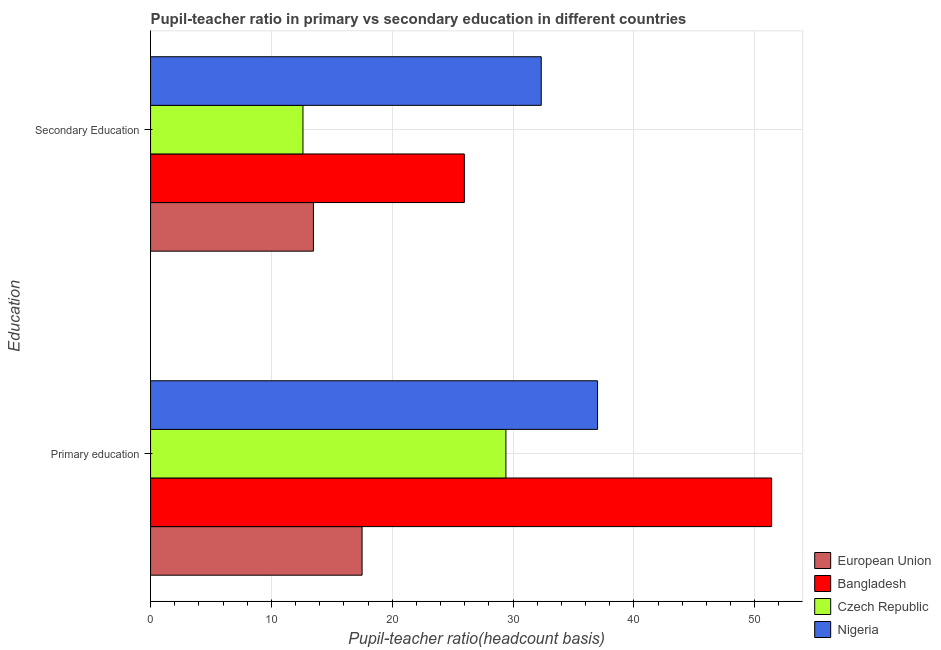How many different coloured bars are there?
Make the answer very short. 4. Are the number of bars per tick equal to the number of legend labels?
Offer a terse response. Yes. Are the number of bars on each tick of the Y-axis equal?
Your response must be concise. Yes. What is the label of the 1st group of bars from the top?
Your answer should be compact. Secondary Education. What is the pupil-teacher ratio in primary education in European Union?
Your answer should be very brief. 17.51. Across all countries, what is the maximum pupil teacher ratio on secondary education?
Offer a terse response. 32.34. Across all countries, what is the minimum pupil teacher ratio on secondary education?
Provide a short and direct response. 12.61. In which country was the pupil-teacher ratio in primary education maximum?
Provide a short and direct response. Bangladesh. What is the total pupil-teacher ratio in primary education in the graph?
Ensure brevity in your answer.  135.32. What is the difference between the pupil teacher ratio on secondary education in European Union and that in Nigeria?
Provide a succinct answer. -18.86. What is the difference between the pupil-teacher ratio in primary education in Czech Republic and the pupil teacher ratio on secondary education in Nigeria?
Your answer should be very brief. -2.92. What is the average pupil-teacher ratio in primary education per country?
Provide a short and direct response. 33.83. What is the difference between the pupil teacher ratio on secondary education and pupil-teacher ratio in primary education in Czech Republic?
Offer a very short reply. -16.8. In how many countries, is the pupil-teacher ratio in primary education greater than 38 ?
Keep it short and to the point. 1. What is the ratio of the pupil-teacher ratio in primary education in Czech Republic to that in Bangladesh?
Offer a terse response. 0.57. What does the 2nd bar from the top in Primary education represents?
Provide a succinct answer. Czech Republic. How many bars are there?
Your response must be concise. 8. Are all the bars in the graph horizontal?
Keep it short and to the point. Yes. Are the values on the major ticks of X-axis written in scientific E-notation?
Give a very brief answer. No. Where does the legend appear in the graph?
Your answer should be very brief. Bottom right. What is the title of the graph?
Ensure brevity in your answer.  Pupil-teacher ratio in primary vs secondary education in different countries. What is the label or title of the X-axis?
Ensure brevity in your answer.  Pupil-teacher ratio(headcount basis). What is the label or title of the Y-axis?
Ensure brevity in your answer.  Education. What is the Pupil-teacher ratio(headcount basis) in European Union in Primary education?
Make the answer very short. 17.51. What is the Pupil-teacher ratio(headcount basis) of Bangladesh in Primary education?
Your response must be concise. 51.4. What is the Pupil-teacher ratio(headcount basis) of Czech Republic in Primary education?
Keep it short and to the point. 29.41. What is the Pupil-teacher ratio(headcount basis) in Nigeria in Primary education?
Your answer should be very brief. 37. What is the Pupil-teacher ratio(headcount basis) of European Union in Secondary Education?
Provide a succinct answer. 13.48. What is the Pupil-teacher ratio(headcount basis) of Bangladesh in Secondary Education?
Keep it short and to the point. 25.97. What is the Pupil-teacher ratio(headcount basis) in Czech Republic in Secondary Education?
Provide a short and direct response. 12.61. What is the Pupil-teacher ratio(headcount basis) in Nigeria in Secondary Education?
Your answer should be very brief. 32.34. Across all Education, what is the maximum Pupil-teacher ratio(headcount basis) of European Union?
Provide a short and direct response. 17.51. Across all Education, what is the maximum Pupil-teacher ratio(headcount basis) in Bangladesh?
Your answer should be very brief. 51.4. Across all Education, what is the maximum Pupil-teacher ratio(headcount basis) in Czech Republic?
Your answer should be compact. 29.41. Across all Education, what is the maximum Pupil-teacher ratio(headcount basis) in Nigeria?
Your answer should be compact. 37. Across all Education, what is the minimum Pupil-teacher ratio(headcount basis) in European Union?
Ensure brevity in your answer.  13.48. Across all Education, what is the minimum Pupil-teacher ratio(headcount basis) in Bangladesh?
Provide a short and direct response. 25.97. Across all Education, what is the minimum Pupil-teacher ratio(headcount basis) of Czech Republic?
Keep it short and to the point. 12.61. Across all Education, what is the minimum Pupil-teacher ratio(headcount basis) in Nigeria?
Offer a very short reply. 32.34. What is the total Pupil-teacher ratio(headcount basis) in European Union in the graph?
Keep it short and to the point. 30.99. What is the total Pupil-teacher ratio(headcount basis) in Bangladesh in the graph?
Provide a succinct answer. 77.38. What is the total Pupil-teacher ratio(headcount basis) of Czech Republic in the graph?
Offer a very short reply. 42.03. What is the total Pupil-teacher ratio(headcount basis) of Nigeria in the graph?
Your answer should be compact. 69.33. What is the difference between the Pupil-teacher ratio(headcount basis) in European Union in Primary education and that in Secondary Education?
Your answer should be very brief. 4.03. What is the difference between the Pupil-teacher ratio(headcount basis) in Bangladesh in Primary education and that in Secondary Education?
Provide a short and direct response. 25.43. What is the difference between the Pupil-teacher ratio(headcount basis) of Czech Republic in Primary education and that in Secondary Education?
Keep it short and to the point. 16.8. What is the difference between the Pupil-teacher ratio(headcount basis) of Nigeria in Primary education and that in Secondary Education?
Keep it short and to the point. 4.66. What is the difference between the Pupil-teacher ratio(headcount basis) in European Union in Primary education and the Pupil-teacher ratio(headcount basis) in Bangladesh in Secondary Education?
Offer a terse response. -8.46. What is the difference between the Pupil-teacher ratio(headcount basis) of European Union in Primary education and the Pupil-teacher ratio(headcount basis) of Czech Republic in Secondary Education?
Provide a succinct answer. 4.89. What is the difference between the Pupil-teacher ratio(headcount basis) in European Union in Primary education and the Pupil-teacher ratio(headcount basis) in Nigeria in Secondary Education?
Offer a terse response. -14.83. What is the difference between the Pupil-teacher ratio(headcount basis) of Bangladesh in Primary education and the Pupil-teacher ratio(headcount basis) of Czech Republic in Secondary Education?
Offer a very short reply. 38.79. What is the difference between the Pupil-teacher ratio(headcount basis) of Bangladesh in Primary education and the Pupil-teacher ratio(headcount basis) of Nigeria in Secondary Education?
Provide a succinct answer. 19.07. What is the difference between the Pupil-teacher ratio(headcount basis) in Czech Republic in Primary education and the Pupil-teacher ratio(headcount basis) in Nigeria in Secondary Education?
Offer a very short reply. -2.92. What is the average Pupil-teacher ratio(headcount basis) of European Union per Education?
Provide a succinct answer. 15.49. What is the average Pupil-teacher ratio(headcount basis) in Bangladesh per Education?
Ensure brevity in your answer.  38.69. What is the average Pupil-teacher ratio(headcount basis) in Czech Republic per Education?
Provide a succinct answer. 21.01. What is the average Pupil-teacher ratio(headcount basis) of Nigeria per Education?
Offer a terse response. 34.67. What is the difference between the Pupil-teacher ratio(headcount basis) in European Union and Pupil-teacher ratio(headcount basis) in Bangladesh in Primary education?
Your answer should be compact. -33.9. What is the difference between the Pupil-teacher ratio(headcount basis) of European Union and Pupil-teacher ratio(headcount basis) of Czech Republic in Primary education?
Ensure brevity in your answer.  -11.91. What is the difference between the Pupil-teacher ratio(headcount basis) of European Union and Pupil-teacher ratio(headcount basis) of Nigeria in Primary education?
Offer a very short reply. -19.49. What is the difference between the Pupil-teacher ratio(headcount basis) of Bangladesh and Pupil-teacher ratio(headcount basis) of Czech Republic in Primary education?
Make the answer very short. 21.99. What is the difference between the Pupil-teacher ratio(headcount basis) in Bangladesh and Pupil-teacher ratio(headcount basis) in Nigeria in Primary education?
Your response must be concise. 14.41. What is the difference between the Pupil-teacher ratio(headcount basis) of Czech Republic and Pupil-teacher ratio(headcount basis) of Nigeria in Primary education?
Ensure brevity in your answer.  -7.59. What is the difference between the Pupil-teacher ratio(headcount basis) of European Union and Pupil-teacher ratio(headcount basis) of Bangladesh in Secondary Education?
Your response must be concise. -12.49. What is the difference between the Pupil-teacher ratio(headcount basis) of European Union and Pupil-teacher ratio(headcount basis) of Czech Republic in Secondary Education?
Your answer should be compact. 0.86. What is the difference between the Pupil-teacher ratio(headcount basis) of European Union and Pupil-teacher ratio(headcount basis) of Nigeria in Secondary Education?
Your response must be concise. -18.86. What is the difference between the Pupil-teacher ratio(headcount basis) of Bangladesh and Pupil-teacher ratio(headcount basis) of Czech Republic in Secondary Education?
Give a very brief answer. 13.36. What is the difference between the Pupil-teacher ratio(headcount basis) of Bangladesh and Pupil-teacher ratio(headcount basis) of Nigeria in Secondary Education?
Provide a short and direct response. -6.36. What is the difference between the Pupil-teacher ratio(headcount basis) in Czech Republic and Pupil-teacher ratio(headcount basis) in Nigeria in Secondary Education?
Make the answer very short. -19.72. What is the ratio of the Pupil-teacher ratio(headcount basis) in European Union in Primary education to that in Secondary Education?
Your response must be concise. 1.3. What is the ratio of the Pupil-teacher ratio(headcount basis) of Bangladesh in Primary education to that in Secondary Education?
Ensure brevity in your answer.  1.98. What is the ratio of the Pupil-teacher ratio(headcount basis) of Czech Republic in Primary education to that in Secondary Education?
Offer a terse response. 2.33. What is the ratio of the Pupil-teacher ratio(headcount basis) of Nigeria in Primary education to that in Secondary Education?
Keep it short and to the point. 1.14. What is the difference between the highest and the second highest Pupil-teacher ratio(headcount basis) of European Union?
Your response must be concise. 4.03. What is the difference between the highest and the second highest Pupil-teacher ratio(headcount basis) in Bangladesh?
Provide a succinct answer. 25.43. What is the difference between the highest and the second highest Pupil-teacher ratio(headcount basis) of Czech Republic?
Your answer should be very brief. 16.8. What is the difference between the highest and the second highest Pupil-teacher ratio(headcount basis) of Nigeria?
Your answer should be compact. 4.66. What is the difference between the highest and the lowest Pupil-teacher ratio(headcount basis) in European Union?
Keep it short and to the point. 4.03. What is the difference between the highest and the lowest Pupil-teacher ratio(headcount basis) of Bangladesh?
Ensure brevity in your answer.  25.43. What is the difference between the highest and the lowest Pupil-teacher ratio(headcount basis) in Czech Republic?
Provide a succinct answer. 16.8. What is the difference between the highest and the lowest Pupil-teacher ratio(headcount basis) of Nigeria?
Offer a terse response. 4.66. 